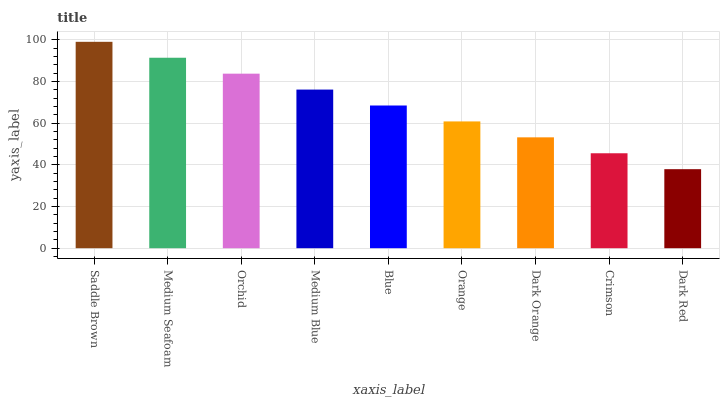Is Saddle Brown the maximum?
Answer yes or no. Yes. Is Medium Seafoam the minimum?
Answer yes or no. No. Is Medium Seafoam the maximum?
Answer yes or no. No. Is Saddle Brown greater than Medium Seafoam?
Answer yes or no. Yes. Is Medium Seafoam less than Saddle Brown?
Answer yes or no. Yes. Is Medium Seafoam greater than Saddle Brown?
Answer yes or no. No. Is Saddle Brown less than Medium Seafoam?
Answer yes or no. No. Is Blue the high median?
Answer yes or no. Yes. Is Blue the low median?
Answer yes or no. Yes. Is Medium Seafoam the high median?
Answer yes or no. No. Is Dark Red the low median?
Answer yes or no. No. 